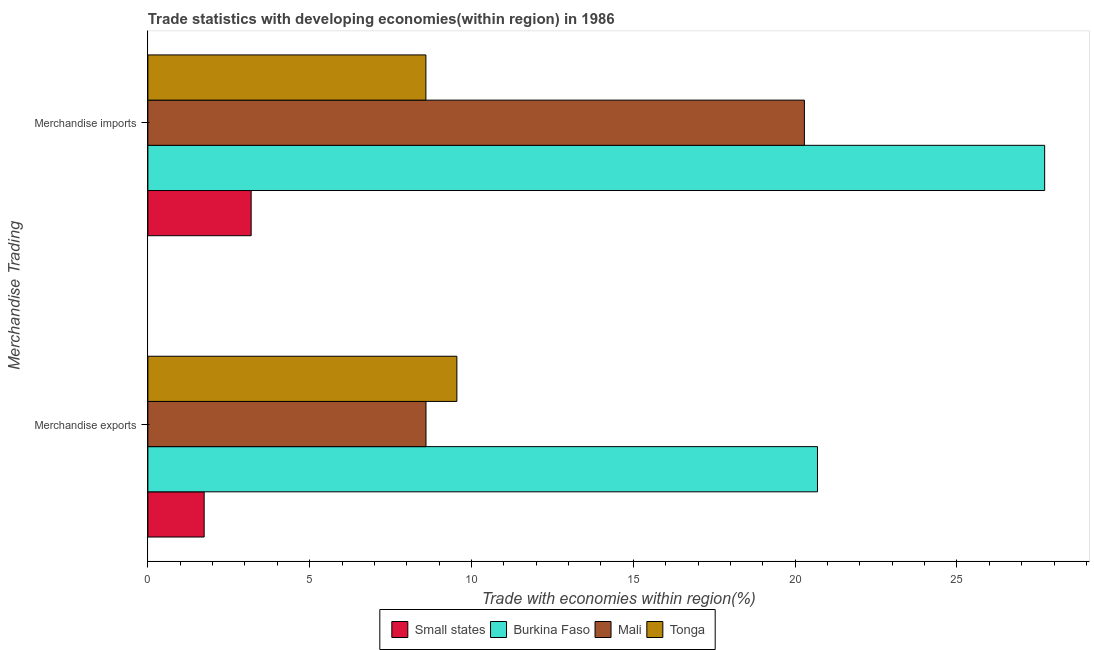How many groups of bars are there?
Offer a terse response. 2. Are the number of bars per tick equal to the number of legend labels?
Make the answer very short. Yes. How many bars are there on the 1st tick from the bottom?
Give a very brief answer. 4. What is the merchandise imports in Tonga?
Offer a very short reply. 8.59. Across all countries, what is the maximum merchandise imports?
Offer a terse response. 27.71. Across all countries, what is the minimum merchandise imports?
Provide a short and direct response. 3.19. In which country was the merchandise exports maximum?
Keep it short and to the point. Burkina Faso. In which country was the merchandise exports minimum?
Offer a terse response. Small states. What is the total merchandise imports in the graph?
Offer a terse response. 59.78. What is the difference between the merchandise exports in Mali and that in Burkina Faso?
Provide a short and direct response. -12.1. What is the difference between the merchandise exports in Mali and the merchandise imports in Small states?
Make the answer very short. 5.4. What is the average merchandise imports per country?
Offer a terse response. 14.95. What is the difference between the merchandise exports and merchandise imports in Tonga?
Your answer should be compact. 0.96. In how many countries, is the merchandise imports greater than 14 %?
Provide a succinct answer. 2. What is the ratio of the merchandise imports in Burkina Faso to that in Mali?
Make the answer very short. 1.37. Is the merchandise exports in Small states less than that in Mali?
Offer a very short reply. Yes. In how many countries, is the merchandise imports greater than the average merchandise imports taken over all countries?
Provide a succinct answer. 2. What does the 2nd bar from the top in Merchandise imports represents?
Your response must be concise. Mali. What does the 1st bar from the bottom in Merchandise imports represents?
Make the answer very short. Small states. How many bars are there?
Ensure brevity in your answer.  8. Are all the bars in the graph horizontal?
Offer a terse response. Yes. Are the values on the major ticks of X-axis written in scientific E-notation?
Give a very brief answer. No. How many legend labels are there?
Your response must be concise. 4. How are the legend labels stacked?
Ensure brevity in your answer.  Horizontal. What is the title of the graph?
Offer a terse response. Trade statistics with developing economies(within region) in 1986. What is the label or title of the X-axis?
Your response must be concise. Trade with economies within region(%). What is the label or title of the Y-axis?
Keep it short and to the point. Merchandise Trading. What is the Trade with economies within region(%) in Small states in Merchandise exports?
Your answer should be very brief. 1.74. What is the Trade with economies within region(%) in Burkina Faso in Merchandise exports?
Provide a succinct answer. 20.69. What is the Trade with economies within region(%) of Mali in Merchandise exports?
Your response must be concise. 8.59. What is the Trade with economies within region(%) of Tonga in Merchandise exports?
Give a very brief answer. 9.55. What is the Trade with economies within region(%) in Small states in Merchandise imports?
Provide a succinct answer. 3.19. What is the Trade with economies within region(%) in Burkina Faso in Merchandise imports?
Provide a succinct answer. 27.71. What is the Trade with economies within region(%) in Mali in Merchandise imports?
Make the answer very short. 20.29. What is the Trade with economies within region(%) in Tonga in Merchandise imports?
Provide a succinct answer. 8.59. Across all Merchandise Trading, what is the maximum Trade with economies within region(%) of Small states?
Your answer should be compact. 3.19. Across all Merchandise Trading, what is the maximum Trade with economies within region(%) of Burkina Faso?
Provide a short and direct response. 27.71. Across all Merchandise Trading, what is the maximum Trade with economies within region(%) in Mali?
Your answer should be compact. 20.29. Across all Merchandise Trading, what is the maximum Trade with economies within region(%) of Tonga?
Offer a terse response. 9.55. Across all Merchandise Trading, what is the minimum Trade with economies within region(%) of Small states?
Offer a very short reply. 1.74. Across all Merchandise Trading, what is the minimum Trade with economies within region(%) of Burkina Faso?
Offer a terse response. 20.69. Across all Merchandise Trading, what is the minimum Trade with economies within region(%) in Mali?
Offer a very short reply. 8.59. Across all Merchandise Trading, what is the minimum Trade with economies within region(%) in Tonga?
Your answer should be very brief. 8.59. What is the total Trade with economies within region(%) in Small states in the graph?
Make the answer very short. 4.93. What is the total Trade with economies within region(%) in Burkina Faso in the graph?
Your answer should be compact. 48.4. What is the total Trade with economies within region(%) in Mali in the graph?
Make the answer very short. 28.88. What is the total Trade with economies within region(%) in Tonga in the graph?
Your answer should be compact. 18.14. What is the difference between the Trade with economies within region(%) in Small states in Merchandise exports and that in Merchandise imports?
Your response must be concise. -1.45. What is the difference between the Trade with economies within region(%) in Burkina Faso in Merchandise exports and that in Merchandise imports?
Offer a very short reply. -7.02. What is the difference between the Trade with economies within region(%) of Mali in Merchandise exports and that in Merchandise imports?
Your answer should be compact. -11.69. What is the difference between the Trade with economies within region(%) in Tonga in Merchandise exports and that in Merchandise imports?
Provide a short and direct response. 0.96. What is the difference between the Trade with economies within region(%) in Small states in Merchandise exports and the Trade with economies within region(%) in Burkina Faso in Merchandise imports?
Provide a succinct answer. -25.97. What is the difference between the Trade with economies within region(%) of Small states in Merchandise exports and the Trade with economies within region(%) of Mali in Merchandise imports?
Offer a very short reply. -18.55. What is the difference between the Trade with economies within region(%) of Small states in Merchandise exports and the Trade with economies within region(%) of Tonga in Merchandise imports?
Your answer should be compact. -6.85. What is the difference between the Trade with economies within region(%) in Burkina Faso in Merchandise exports and the Trade with economies within region(%) in Mali in Merchandise imports?
Provide a short and direct response. 0.4. What is the difference between the Trade with economies within region(%) in Burkina Faso in Merchandise exports and the Trade with economies within region(%) in Tonga in Merchandise imports?
Provide a short and direct response. 12.1. What is the difference between the Trade with economies within region(%) of Mali in Merchandise exports and the Trade with economies within region(%) of Tonga in Merchandise imports?
Your response must be concise. 0. What is the average Trade with economies within region(%) in Small states per Merchandise Trading?
Your answer should be very brief. 2.47. What is the average Trade with economies within region(%) in Burkina Faso per Merchandise Trading?
Make the answer very short. 24.2. What is the average Trade with economies within region(%) in Mali per Merchandise Trading?
Offer a terse response. 14.44. What is the average Trade with economies within region(%) of Tonga per Merchandise Trading?
Give a very brief answer. 9.07. What is the difference between the Trade with economies within region(%) of Small states and Trade with economies within region(%) of Burkina Faso in Merchandise exports?
Offer a terse response. -18.95. What is the difference between the Trade with economies within region(%) of Small states and Trade with economies within region(%) of Mali in Merchandise exports?
Ensure brevity in your answer.  -6.85. What is the difference between the Trade with economies within region(%) of Small states and Trade with economies within region(%) of Tonga in Merchandise exports?
Your answer should be very brief. -7.81. What is the difference between the Trade with economies within region(%) in Burkina Faso and Trade with economies within region(%) in Mali in Merchandise exports?
Your response must be concise. 12.1. What is the difference between the Trade with economies within region(%) of Burkina Faso and Trade with economies within region(%) of Tonga in Merchandise exports?
Give a very brief answer. 11.14. What is the difference between the Trade with economies within region(%) in Mali and Trade with economies within region(%) in Tonga in Merchandise exports?
Make the answer very short. -0.95. What is the difference between the Trade with economies within region(%) of Small states and Trade with economies within region(%) of Burkina Faso in Merchandise imports?
Give a very brief answer. -24.52. What is the difference between the Trade with economies within region(%) of Small states and Trade with economies within region(%) of Mali in Merchandise imports?
Ensure brevity in your answer.  -17.1. What is the difference between the Trade with economies within region(%) in Small states and Trade with economies within region(%) in Tonga in Merchandise imports?
Make the answer very short. -5.4. What is the difference between the Trade with economies within region(%) in Burkina Faso and Trade with economies within region(%) in Mali in Merchandise imports?
Keep it short and to the point. 7.42. What is the difference between the Trade with economies within region(%) of Burkina Faso and Trade with economies within region(%) of Tonga in Merchandise imports?
Your answer should be very brief. 19.12. What is the difference between the Trade with economies within region(%) of Mali and Trade with economies within region(%) of Tonga in Merchandise imports?
Provide a succinct answer. 11.7. What is the ratio of the Trade with economies within region(%) of Small states in Merchandise exports to that in Merchandise imports?
Your response must be concise. 0.55. What is the ratio of the Trade with economies within region(%) of Burkina Faso in Merchandise exports to that in Merchandise imports?
Offer a very short reply. 0.75. What is the ratio of the Trade with economies within region(%) in Mali in Merchandise exports to that in Merchandise imports?
Your response must be concise. 0.42. What is the ratio of the Trade with economies within region(%) of Tonga in Merchandise exports to that in Merchandise imports?
Provide a short and direct response. 1.11. What is the difference between the highest and the second highest Trade with economies within region(%) in Small states?
Keep it short and to the point. 1.45. What is the difference between the highest and the second highest Trade with economies within region(%) of Burkina Faso?
Provide a succinct answer. 7.02. What is the difference between the highest and the second highest Trade with economies within region(%) of Mali?
Your response must be concise. 11.69. What is the difference between the highest and the second highest Trade with economies within region(%) in Tonga?
Your answer should be very brief. 0.96. What is the difference between the highest and the lowest Trade with economies within region(%) in Small states?
Offer a terse response. 1.45. What is the difference between the highest and the lowest Trade with economies within region(%) in Burkina Faso?
Keep it short and to the point. 7.02. What is the difference between the highest and the lowest Trade with economies within region(%) in Mali?
Make the answer very short. 11.69. What is the difference between the highest and the lowest Trade with economies within region(%) of Tonga?
Your response must be concise. 0.96. 